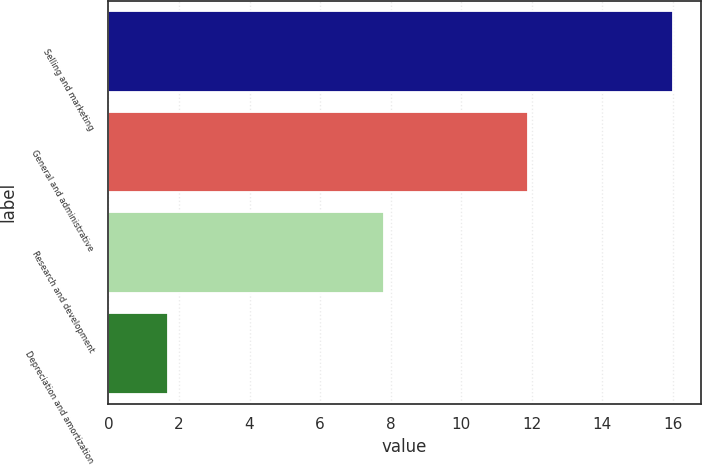<chart> <loc_0><loc_0><loc_500><loc_500><bar_chart><fcel>Selling and marketing<fcel>General and administrative<fcel>Research and development<fcel>Depreciation and amortization<nl><fcel>16<fcel>11.9<fcel>7.8<fcel>1.7<nl></chart> 